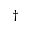<formula> <loc_0><loc_0><loc_500><loc_500>^ { \dagger }</formula> 